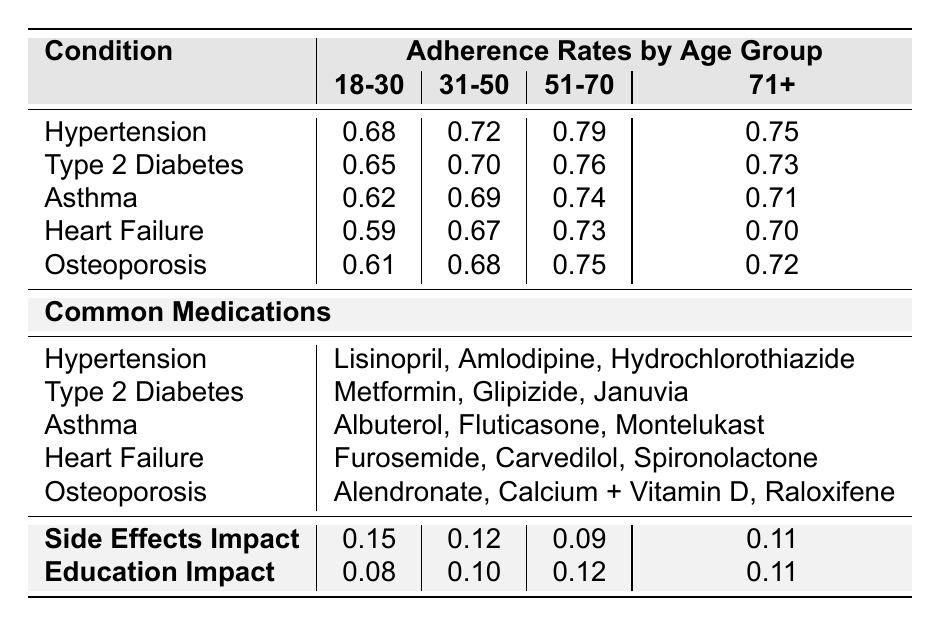What is the adherence rate for patients with Type 2 Diabetes in the age group 31-50? The table shows the adherence rate for Type 2 Diabetes in the 31-50 age group as 0.70.
Answer: 0.70 Which condition has the highest adherence rate among patients aged 51-70? Looking at the adherence rates for the 51-70 age group, Hypertension has the highest rate of 0.79.
Answer: Hypertension What is the average adherence rate for patients aged 71 years and older across all conditions? To find the average for the 71+ age group: (0.75 + 0.73 + 0.71 + 0.70 + 0.72) = 3.61, then divide by 5, which gives 3.61/5 = 0.722.
Answer: 0.722 Does the impact of side effects on Asthma patients fall below 0.10? The side effects impact for Asthma is 0.08, which is indeed below 0.10.
Answer: Yes Which age group shows the lowest adherence rate for Heart Failure patients? Checking the adherence rates for Heart Failure: 0.59 for 18-30, 0.67 for 31-50, 0.73 for 51-70, and 0.70 for 71+. The lowest is 0.59 in the 18-30 age group.
Answer: 18-30 What is the difference between the adherence rate for Hypertension in the 18-30 and 71+ age groups? The adherence rate for Hypertension in the 18-30 age group is 0.68 and in the 71+ age group is 0.75. The difference is 0.75 - 0.68 = 0.07.
Answer: 0.07 Which condition has the lowest education impact rate for patients aged 51-70? The education impact for patients aged 51-70 shows 0.12 for Hypertension, 0.13 for Type 2 Diabetes, 0.11 for Asthma, 0.14 for Heart Failure, and 0.12 for Osteoporosis. The lowest is 0.11 for Asthma.
Answer: Asthma Is the adherence rate for Osteoporosis in the 31-50 age group higher than that for Heart Failure in the same age group? The adherence rate for Osteoporosis in the 31-50 age group is 0.68, while for Heart Failure, it is 0.67. Since 0.68 is greater than 0.67, the answer is yes.
Answer: Yes What is the common medication for patients with Asthma? The common medications listed for asthma patients are Albuterol, Fluticasone, and Montelukast.
Answer: Albuterol, Fluticasone, and Montelukast Which age group has the highest side effects impact for Heart Failure patients? The side effects impact for Heart Failure by age groups are 0.20 for 18-30, 0.17 for 31-50, 0.14 for 51-70, and 0.16 for 71+. The highest impact is 0.20 in the 18-30 age group.
Answer: 18-30 What is the education impact for the 71+ age group of patients with Hypertension? The education impact for patients aged 71+ with Hypertension is given as 0.11 in the table.
Answer: 0.11 